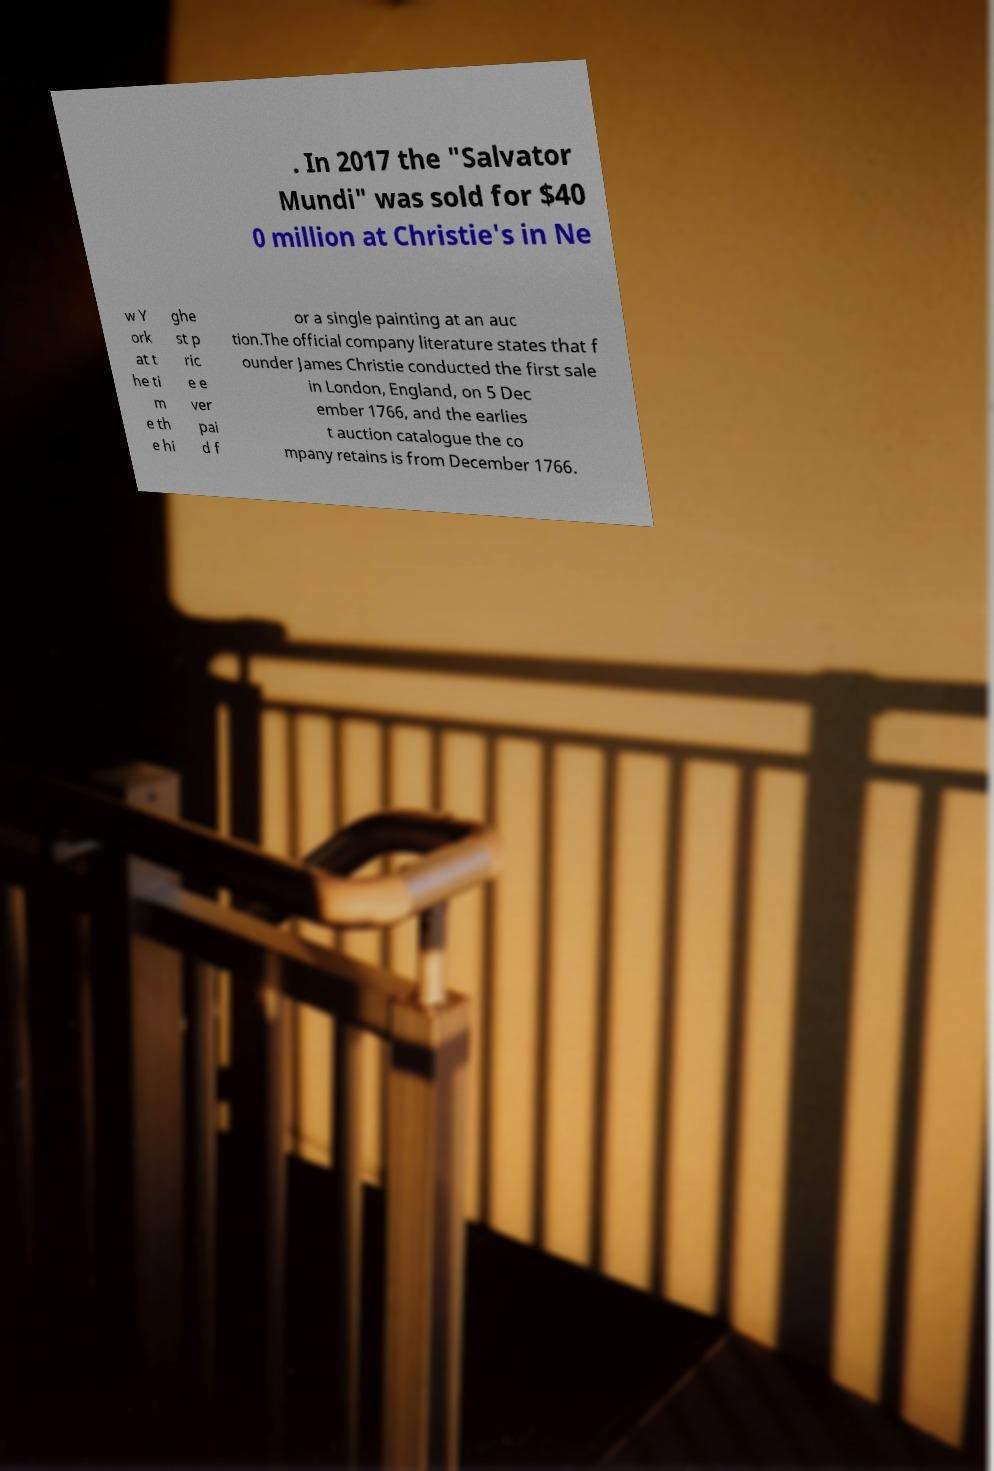Please read and relay the text visible in this image. What does it say? . In 2017 the "Salvator Mundi" was sold for $40 0 million at Christie's in Ne w Y ork at t he ti m e th e hi ghe st p ric e e ver pai d f or a single painting at an auc tion.The official company literature states that f ounder James Christie conducted the first sale in London, England, on 5 Dec ember 1766, and the earlies t auction catalogue the co mpany retains is from December 1766. 